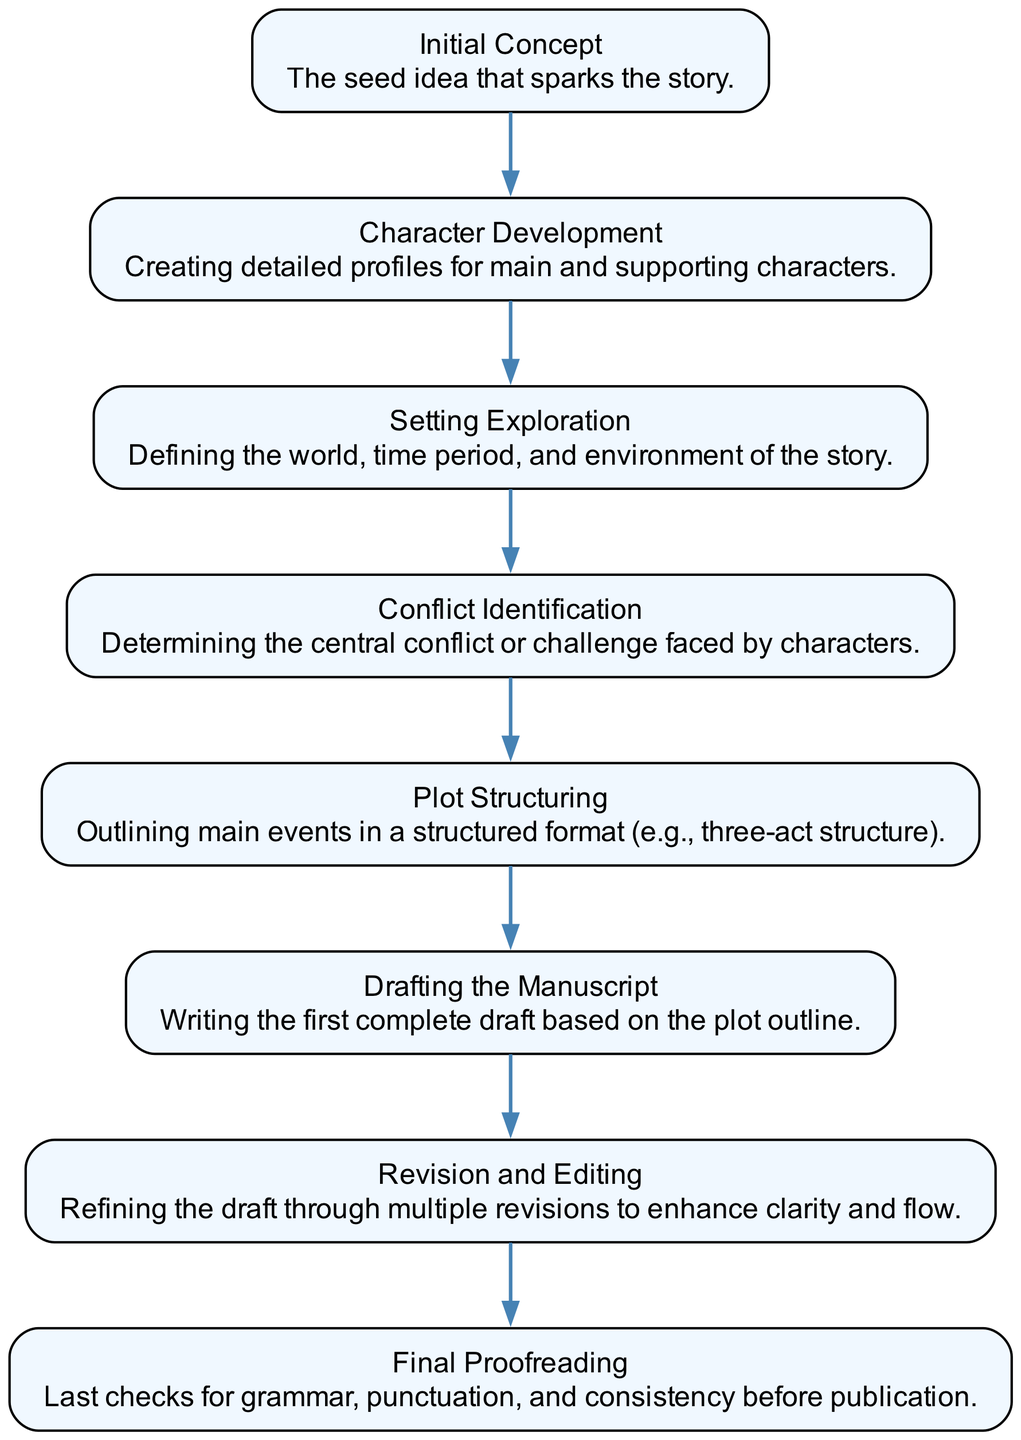What is the first step in the plot structuring flow? The diagram starts with "Initial Concept" as the first element, which represents the seed idea that sparks the story.
Answer: Initial Concept How many nodes are present in the diagram? The diagram lists eight distinct elements or nodes that proceed through the plot structuring flow, from "Initial Concept" to "Final Proofreading."
Answer: 8 What is the central conflict identified after character development? "Conflict Identification" follows "Character Development" in the flow, making it the next major step in the process after developing characters.
Answer: Conflict Identification What follows the "Drafting the Manuscript" stage? According to the flow, "Revision and Editing" comes directly after "Drafting the Manuscript," indicating the next crucial phase in the writing process.
Answer: Revision and Editing Which element comes last in the flow chart? The last node in the diagram represents "Final Proofreading," which is the final step before publication.
Answer: Final Proofreading How many edges connect the nodes in the plot structuring flow? Each node (except the first) connects to the next, resulting in a total of 7 edges connecting the 8 nodes present in the flow chart.
Answer: 7 What is the relationship between "Setting Exploration" and "Conflict Identification"? In the flow, "Setting Exploration" precedes "Conflict Identification," showing that understanding the setting is important before identifying the central conflict.
Answer: Precedes Which step directly follows "Conflict Identification"? The next step in the flow chart after "Conflict Identification" is "Plot Structuring," indicating the progression from identifying conflict to outlining the plot.
Answer: Plot Structuring What is the main focus during the "Character Development" step? This step is about creating detailed profiles for the main and supporting characters, which highlights the importance of character depth in storytelling.
Answer: Creating detailed profiles What does the "Plot Structuring" step involve? The "Plot Structuring" step focuses on outlining the main events in a structured format, such as the three-act structure, essential for coherent storytelling.
Answer: Outlining main events 